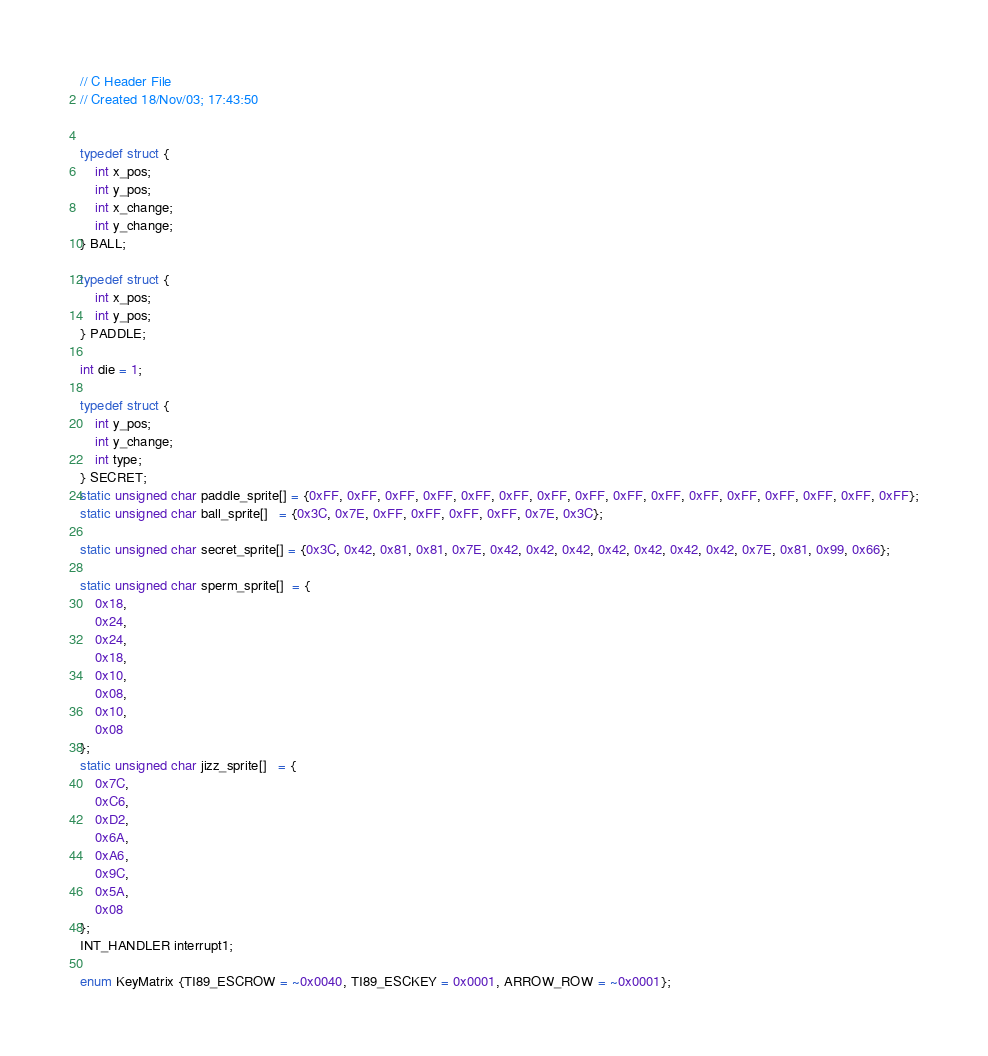<code> <loc_0><loc_0><loc_500><loc_500><_C_>// C Header File
// Created 18/Nov/03; 17:43:50


typedef struct {
	int x_pos;
	int y_pos;
	int x_change;
	int y_change;
} BALL;

typedef struct {
	int x_pos;
	int y_pos;
} PADDLE;

int die = 1;

typedef struct {
	int y_pos;
	int y_change;
	int type;
} SECRET;
static unsigned char paddle_sprite[] = {0xFF, 0xFF, 0xFF, 0xFF, 0xFF, 0xFF, 0xFF, 0xFF, 0xFF, 0xFF, 0xFF, 0xFF, 0xFF, 0xFF, 0xFF, 0xFF};
static unsigned char ball_sprite[]   = {0x3C, 0x7E, 0xFF, 0xFF, 0xFF, 0xFF, 0x7E, 0x3C};

static unsigned char secret_sprite[] = {0x3C, 0x42, 0x81, 0x81, 0x7E, 0x42, 0x42, 0x42, 0x42, 0x42, 0x42, 0x42, 0x7E, 0x81, 0x99, 0x66};

static unsigned char sperm_sprite[]  = {
	0x18,
	0x24,
	0x24,
	0x18,
	0x10,
	0x08,
	0x10,
	0x08
};
static unsigned char jizz_sprite[]   = {
	0x7C,
	0xC6,
	0xD2,
	0x6A,
	0xA6,
	0x9C,
	0x5A,
	0x08
};
INT_HANDLER interrupt1;

enum KeyMatrix {TI89_ESCROW = ~0x0040, TI89_ESCKEY = 0x0001, ARROW_ROW = ~0x0001};

</code> 